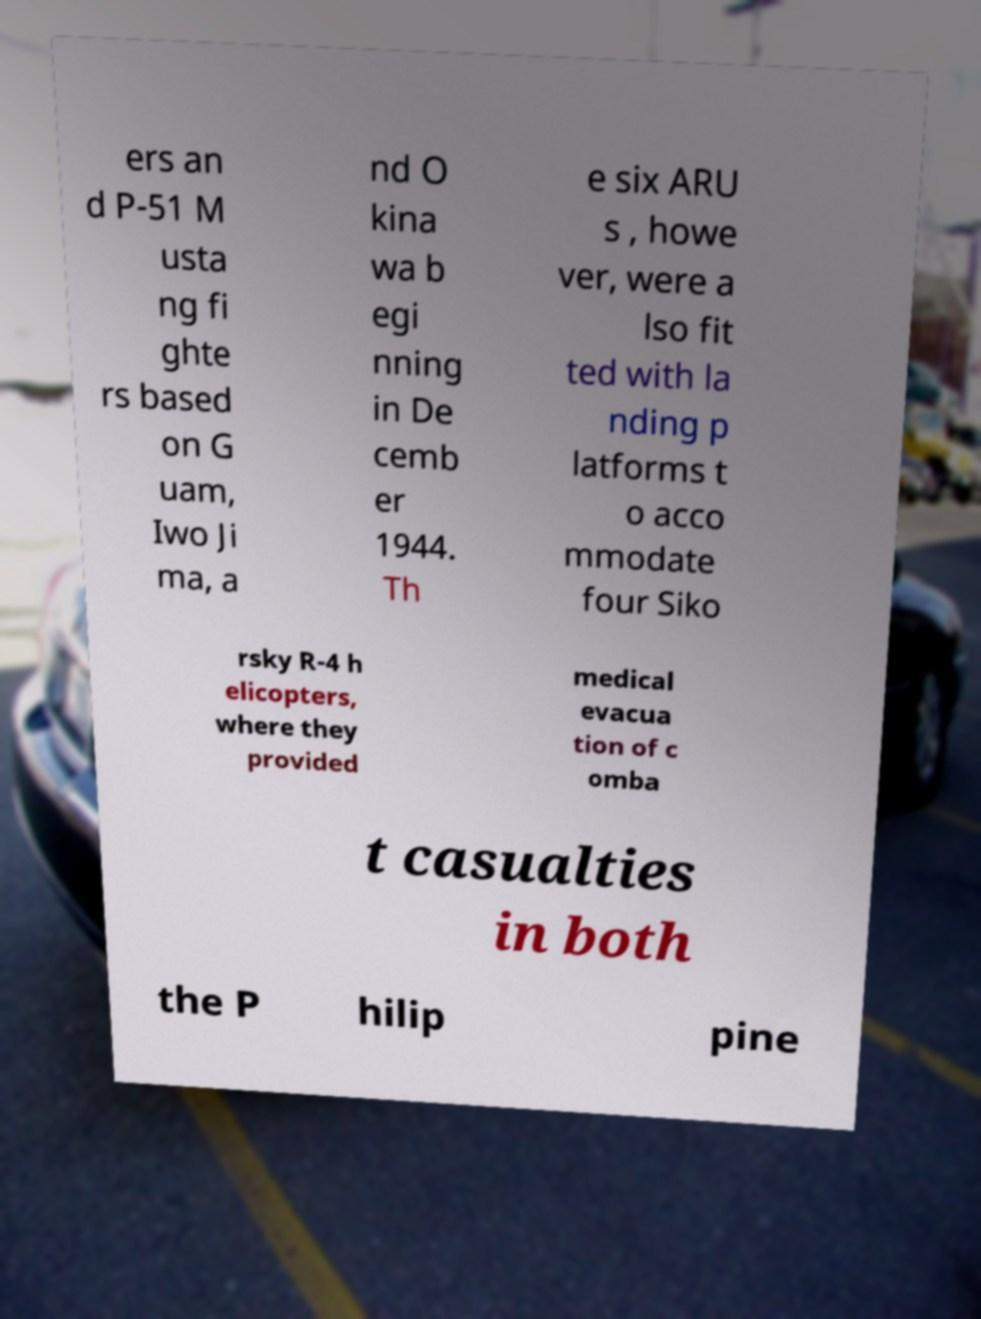What messages or text are displayed in this image? I need them in a readable, typed format. ers an d P-51 M usta ng fi ghte rs based on G uam, Iwo Ji ma, a nd O kina wa b egi nning in De cemb er 1944. Th e six ARU s , howe ver, were a lso fit ted with la nding p latforms t o acco mmodate four Siko rsky R-4 h elicopters, where they provided medical evacua tion of c omba t casualties in both the P hilip pine 